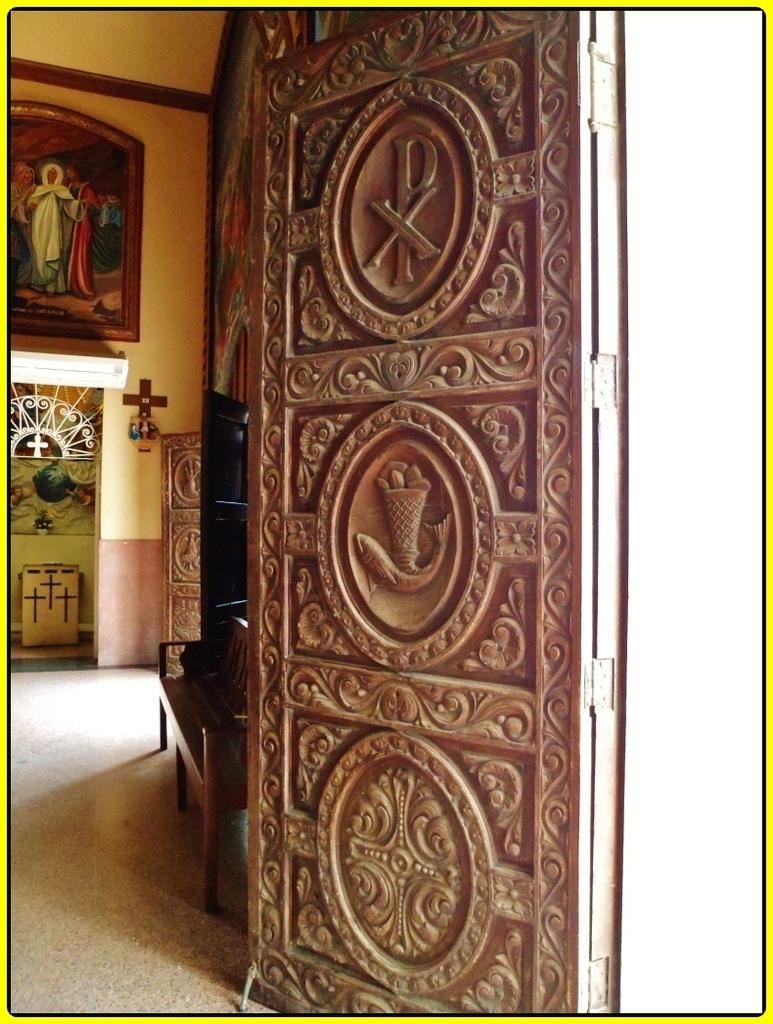Describe this image in one or two sentences. In this image in the front there is a door. In the background there is an empty bench and there is a frame on the wall. 